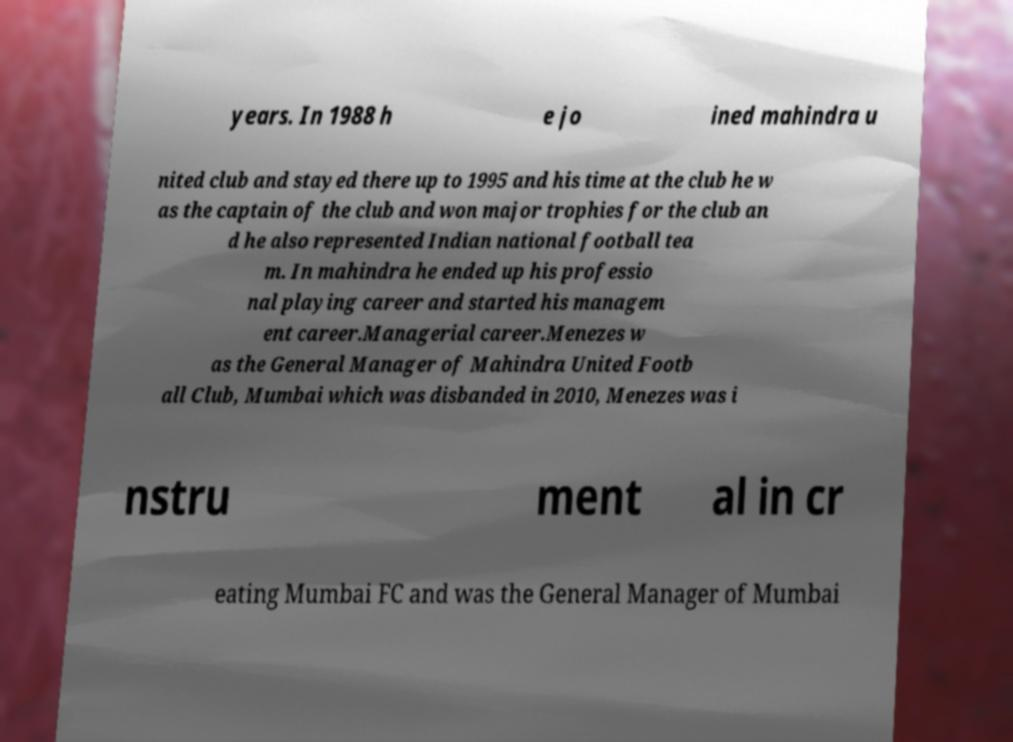Could you assist in decoding the text presented in this image and type it out clearly? years. In 1988 h e jo ined mahindra u nited club and stayed there up to 1995 and his time at the club he w as the captain of the club and won major trophies for the club an d he also represented Indian national football tea m. In mahindra he ended up his professio nal playing career and started his managem ent career.Managerial career.Menezes w as the General Manager of Mahindra United Footb all Club, Mumbai which was disbanded in 2010, Menezes was i nstru ment al in cr eating Mumbai FC and was the General Manager of Mumbai 